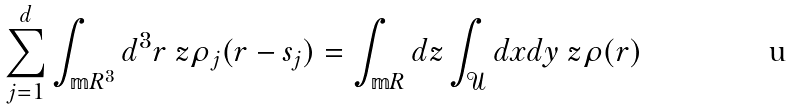Convert formula to latex. <formula><loc_0><loc_0><loc_500><loc_500>\sum _ { j = 1 } ^ { d } \int _ { \mathbb { m } { R } ^ { 3 } } d ^ { 3 } r \ z \rho _ { j } ( r - s _ { j } ) = \int _ { \mathbb { m } { R } } d z \int _ { \mathcal { U } } d x d y \ z \rho ( r )</formula> 